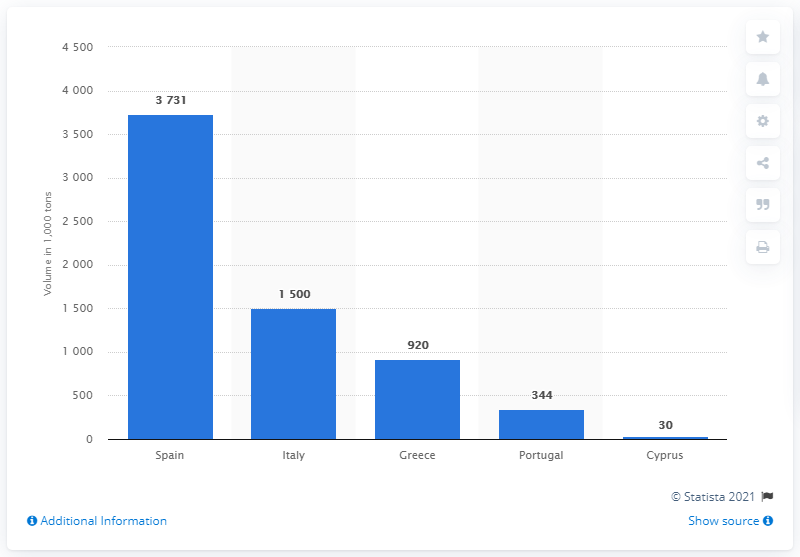Draw attention to some important aspects in this diagram. Spain was the leading producer of fresh oranges in the European Union in the 2018/2019 season. The second largest producer of oranges in the European Union is Italy. 